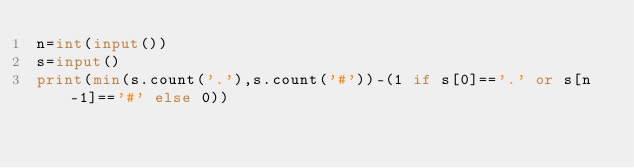Convert code to text. <code><loc_0><loc_0><loc_500><loc_500><_Python_>n=int(input())
s=input()
print(min(s.count('.'),s.count('#'))-(1 if s[0]=='.' or s[n-1]=='#' else 0))</code> 